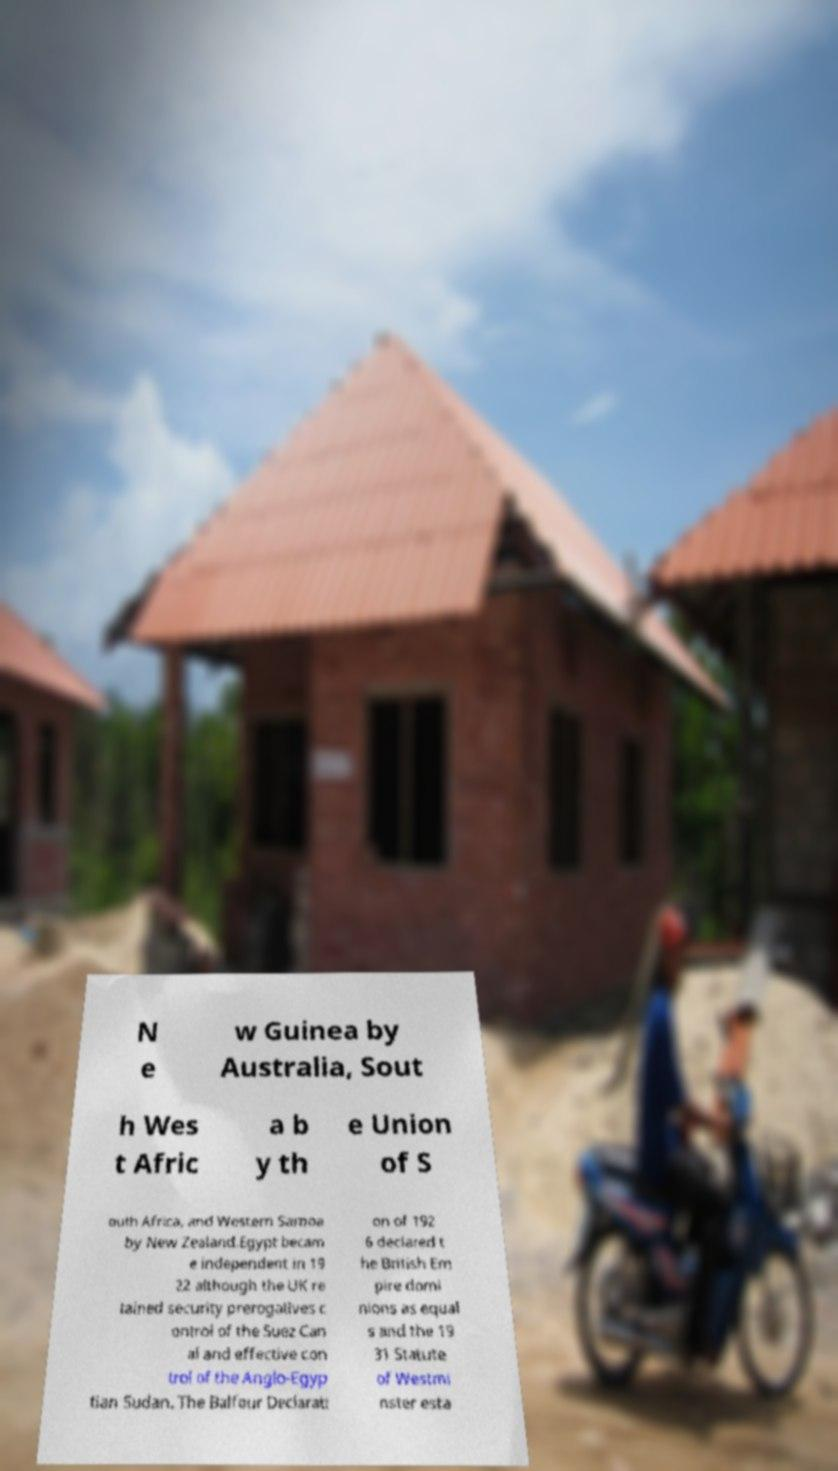I need the written content from this picture converted into text. Can you do that? N e w Guinea by Australia, Sout h Wes t Afric a b y th e Union of S outh Africa, and Western Samoa by New Zealand.Egypt becam e independent in 19 22 although the UK re tained security prerogatives c ontrol of the Suez Can al and effective con trol of the Anglo-Egyp tian Sudan. The Balfour Declarati on of 192 6 declared t he British Em pire domi nions as equal s and the 19 31 Statute of Westmi nster esta 